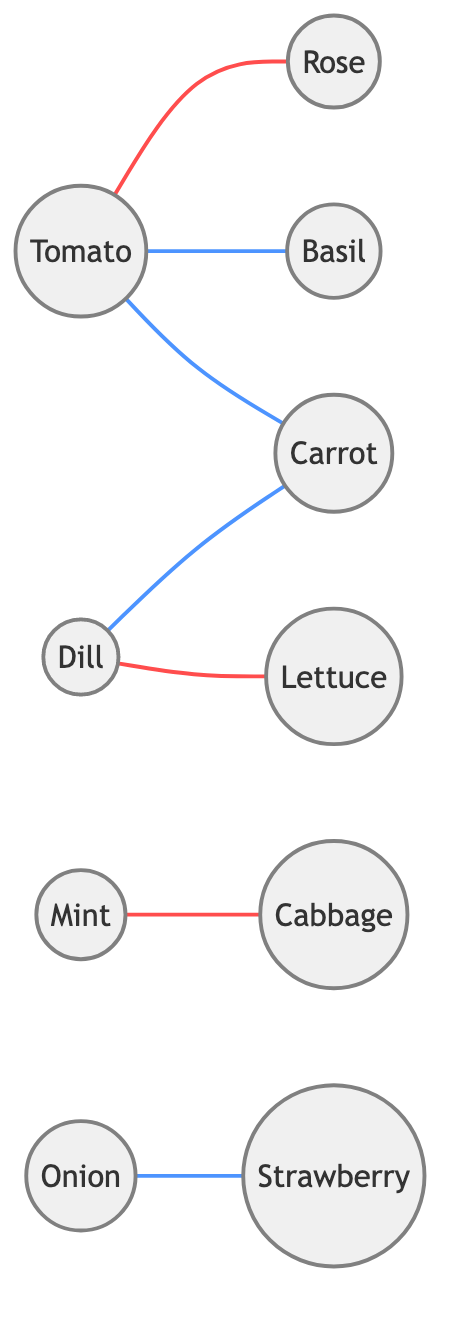What are the nodes in the graph? The nodes in the graph represent different plants: Tomato, Basil, Carrot, Rose, Mint, Onion, Strawberry, Cabbage, Dill, and Lettuce.
Answer: Tomato, Basil, Carrot, Rose, Mint, Onion, Strawberry, Cabbage, Dill, Lettuce How many beneficial relationships are shown in the diagram? The diagram shows four beneficial relationships: Tomato-Basil, Tomato-Carrot, Onion-Strawberry, and Dill-Carrot.
Answer: 4 Which two plants have a detrimental relationship? The detrimental relationships are evidenced by Mint-Cabbage and Tomato-Rose, where each pair negatively affects each other.
Answer: Mint-Cabbage, Tomato-Rose Which plant has a beneficial relationship with Dill? Dill has a beneficial relationship with Carrot, as indicated by the connection in the diagram.
Answer: Carrot How many edges are present in the graph? The graph has a total of seven edges connecting the nodes, representing various relationships between the plants.
Answer: 7 If Tomato is planted with Basil, what is the expected relationship? The expected relationship between Tomato and Basil is beneficial, as illustrated by their connection in the diagram.
Answer: Beneficial Which plant directly affects both Cabbage and Lettuce? Dill is the plant that directly affects both Cabbage (beneficial) and Lettuce (detrimental).
Answer: Dill How many plants benefit from Tomato's presence? Tomato benefits two plants, namely Basil and Carrot, as reflected in the beneficial relationships shown.
Answer: 2 Is there any plant that negatively affects Strawberry? No, there is no indication in the diagram that suggests any plant negatively affects Strawberry.
Answer: No 